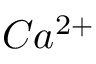<formula> <loc_0><loc_0><loc_500><loc_500>C a ^ { 2 + }</formula> 